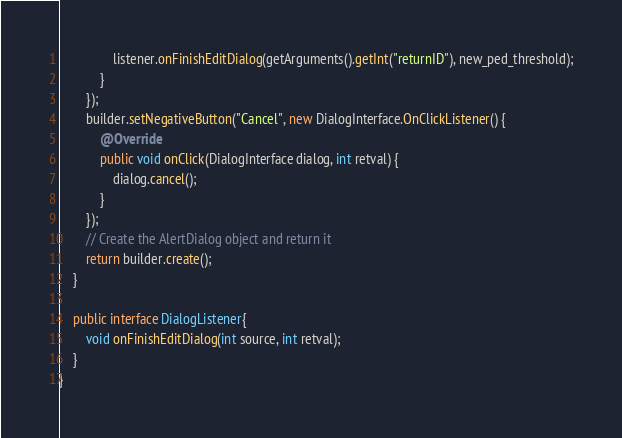Convert code to text. <code><loc_0><loc_0><loc_500><loc_500><_Java_>                listener.onFinishEditDialog(getArguments().getInt("returnID"), new_ped_threshold);
            }
        });
        builder.setNegativeButton("Cancel", new DialogInterface.OnClickListener() {
            @Override
            public void onClick(DialogInterface dialog, int retval) {
                dialog.cancel();
            }
        });
        // Create the AlertDialog object and return it
        return builder.create();
    }

    public interface DialogListener{
        void onFinishEditDialog(int source, int retval);
    }
}
</code> 